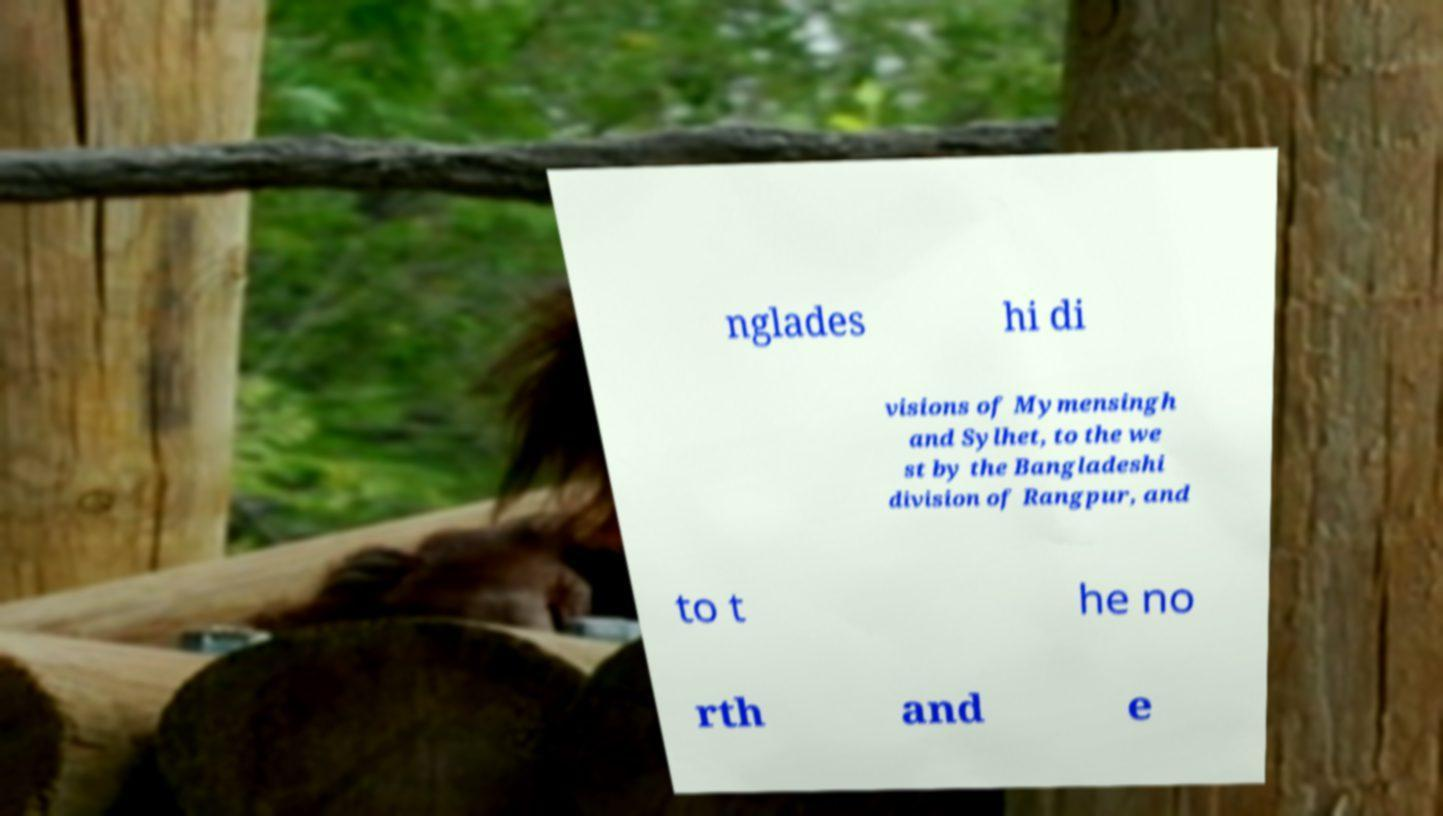There's text embedded in this image that I need extracted. Can you transcribe it verbatim? nglades hi di visions of Mymensingh and Sylhet, to the we st by the Bangladeshi division of Rangpur, and to t he no rth and e 